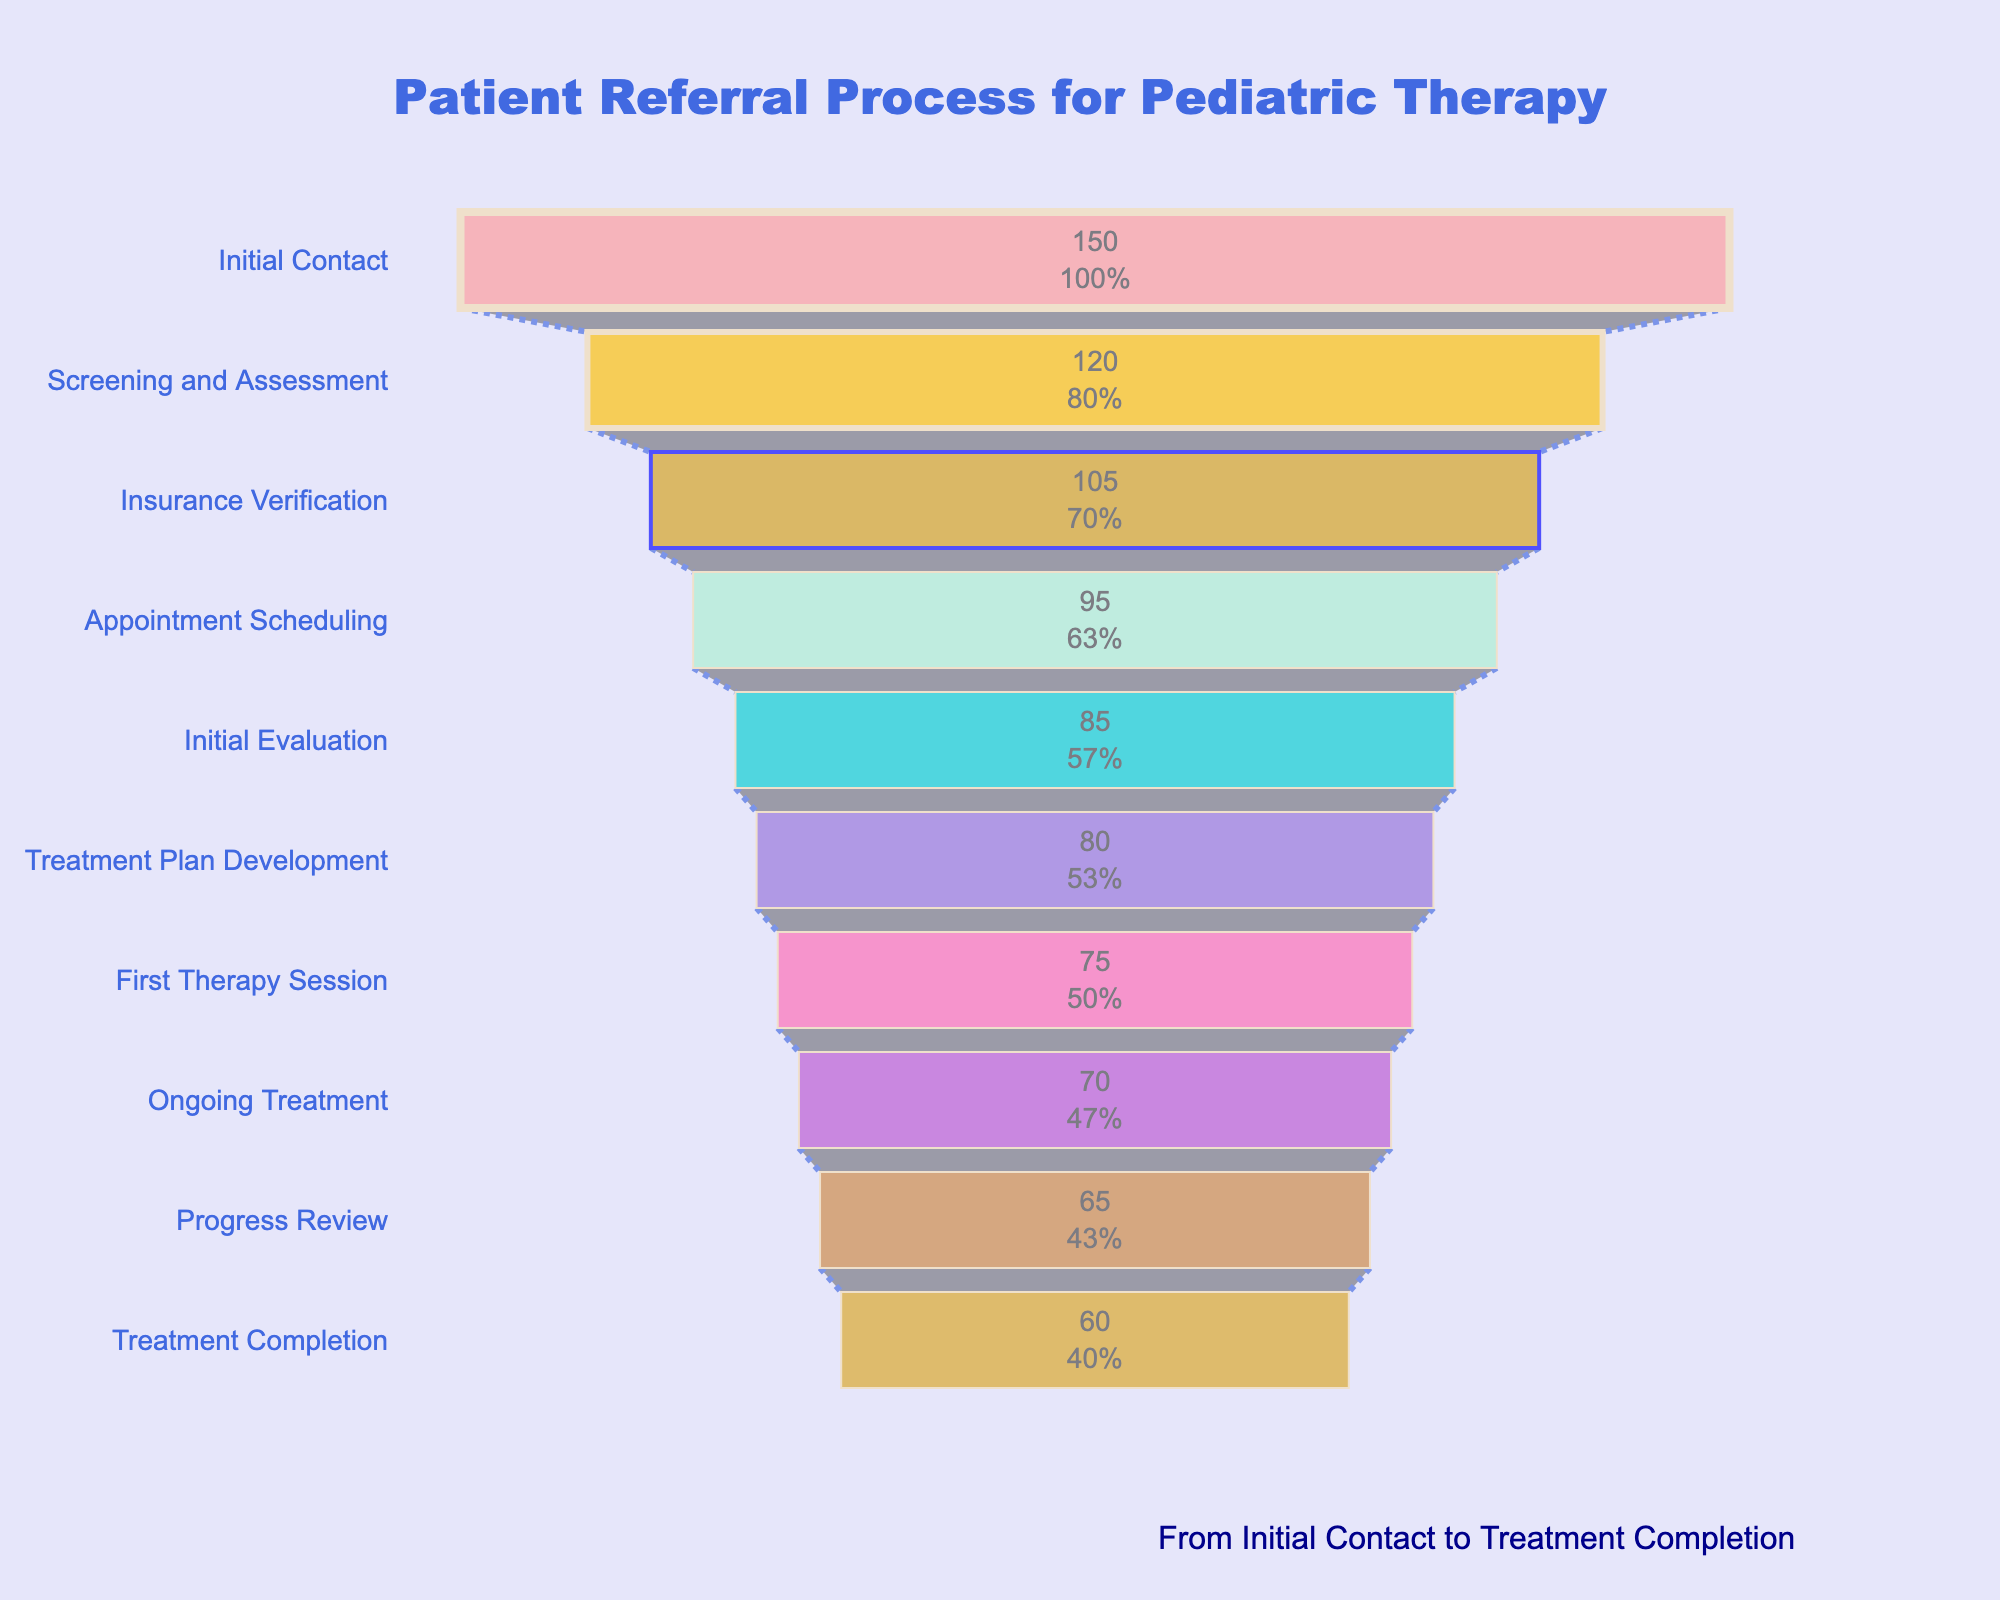What is the title of the funnel chart? The title of the funnel chart is displayed at the top of the chart. It reads "Patient Referral Process for Pediatric Therapy".
Answer: Patient Referral Process for Pediatric Therapy How many patients reached the Initial Contact stage? The chart shows the number of patients at each stage. For the Initial Contact stage, it shows 150 patients.
Answer: 150 Which stage saw the largest drop in patient numbers? To find the largest drop, we subtract the number of patients at each subsequent stage and compare them. From Initial Contact (150) to Screening and Assessment (120), the drop is 30. Comparing other stages, no other stage has a drop larger than 30.
Answer: Initial Contact to Screening and Assessment How many patients completed the Treatment Completion stage? The chart indicates that 60 patients completed the Treatment Completion stage.
Answer: 60 What percentage of patients progressed from Initial Evaluation to Treatment Plan Development? From the chart, Initial Evaluation has 85 patients and Treatment Plan Development has 80. The percentage is calculated as (80/85) * 100.
Answer: 94.1% What is the difference in the number of patients between Appointment Scheduling and First Therapy Session? Appointment Scheduling has 95 patients, and First Therapy Session has 75. The difference is 95 - 75.
Answer: 20 Which stage has the fewest patients? The fewest patients are shown in the Treatment Completion stage, with 60 patients.
Answer: Treatment Completion Is the drop in patient numbers from Initial Contact to Screening and Assessment greater than the drop from Screening and Assessment to Insurance Verification? The drop from Initial Contact to Screening and Assessment is 30, and from Screening and Assessment to Insurance Verification is 15. Since 30 is greater than 15, the drop from Initial Contact to Screening and Assessment is greater.
Answer: Yes Calculate the total number of patients lost from Screening and Assessment to Treatment Completion. Sum the number of patients lost at each stage from Screening and Assessment (120) to Treatment Completion (60). The total loss is 120 - 60.
Answer: 60 